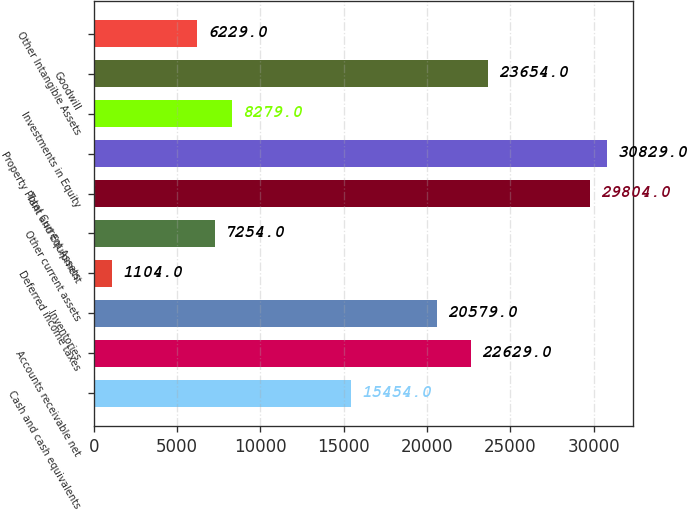Convert chart. <chart><loc_0><loc_0><loc_500><loc_500><bar_chart><fcel>Cash and cash equivalents<fcel>Accounts receivable net<fcel>Inventories<fcel>Deferred income taxes<fcel>Other current assets<fcel>Total Current Assets<fcel>Property Plant and Equipment<fcel>Investments in Equity<fcel>Goodwill<fcel>Other Intangible Assets<nl><fcel>15454<fcel>22629<fcel>20579<fcel>1104<fcel>7254<fcel>29804<fcel>30829<fcel>8279<fcel>23654<fcel>6229<nl></chart> 